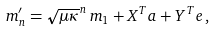<formula> <loc_0><loc_0><loc_500><loc_500>m ^ { \prime } _ { n } = \sqrt { \mu \kappa } ^ { n } \, m _ { 1 } + X ^ { T } a + Y ^ { T } e \, ,</formula> 